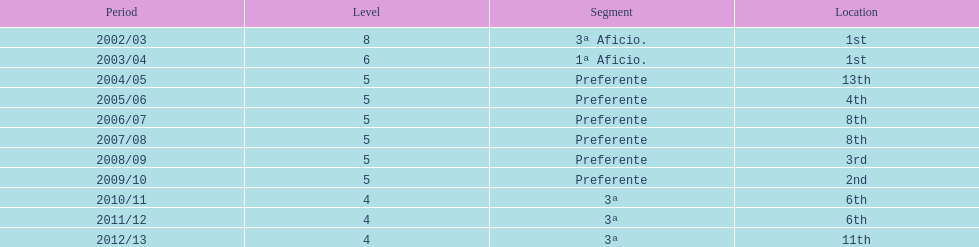How many seasons did internacional de madrid cf play in the preferente division? 6. 